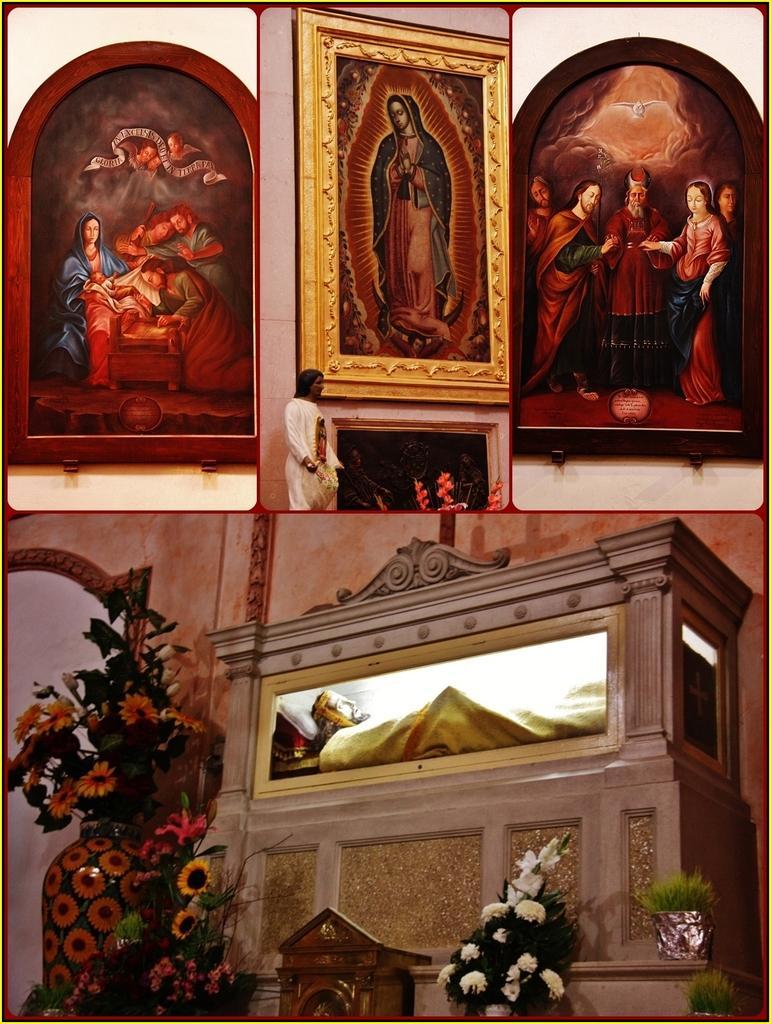In one or two sentences, can you explain what this image depicts? It is a collage picture. In the center of the image there is a wall, mirror, vase, one wooden object, flower bouquets, frames attached to the wall, one statue and a few other objects. 